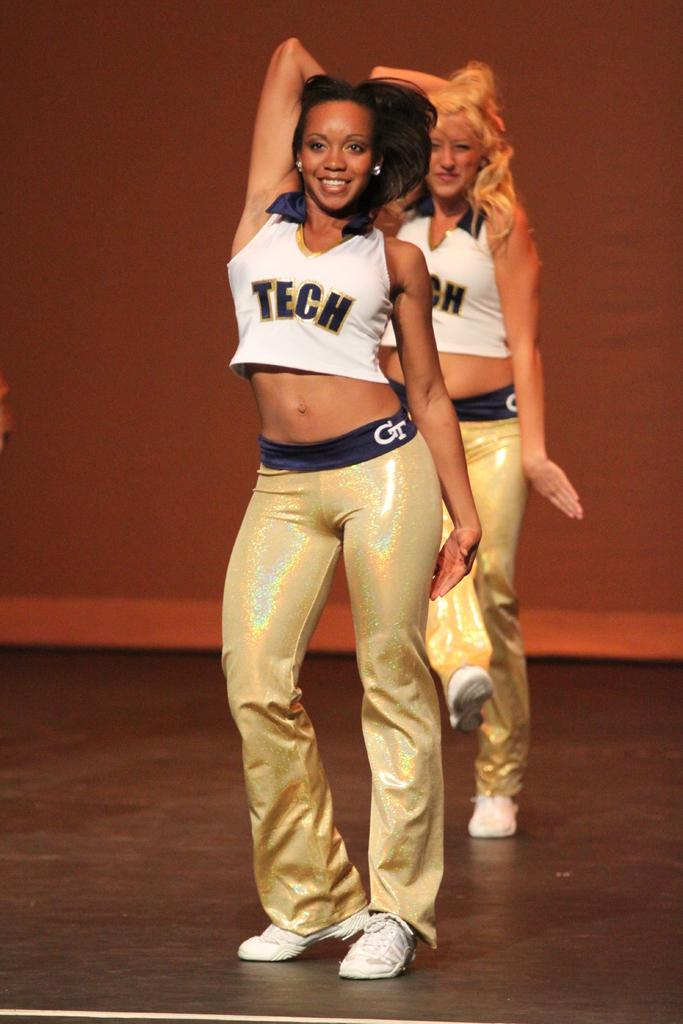<image>
Share a concise interpretation of the image provided. GT Tech is shown on these cheerleader's outfits. 